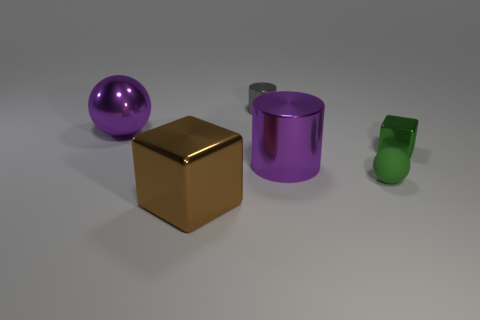There is a large purple metallic thing to the left of the large brown block; is it the same shape as the purple object that is on the right side of the big brown cube?
Make the answer very short. No. The purple object on the right side of the gray metal object has what shape?
Offer a terse response. Cylinder. Is the number of green matte things behind the purple metal cylinder the same as the number of brown metal things that are in front of the tiny shiny cylinder?
Offer a terse response. No. What number of objects are large blue shiny cylinders or purple objects behind the small green metal object?
Your answer should be compact. 1. What shape is the object that is both in front of the tiny green shiny thing and behind the tiny rubber ball?
Offer a terse response. Cylinder. What is the purple thing right of the cylinder behind the large purple shiny sphere made of?
Your answer should be very brief. Metal. Do the purple thing on the right side of the gray metal thing and the tiny gray cylinder have the same material?
Your response must be concise. Yes. There is a cube behind the small sphere; how big is it?
Make the answer very short. Small. Is there a tiny gray shiny thing that is right of the big metallic thing that is to the right of the gray object?
Offer a terse response. No. Is the color of the big metallic object to the left of the large brown cube the same as the ball that is to the right of the brown metallic cube?
Your answer should be very brief. No. 